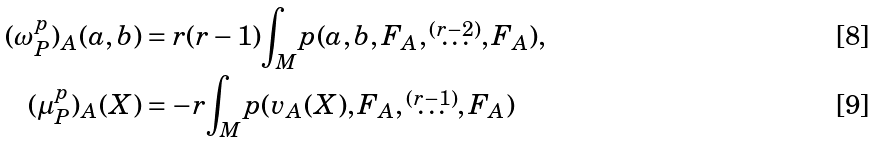<formula> <loc_0><loc_0><loc_500><loc_500>( \omega _ { P } ^ { p } ) _ { A } ( a , b ) & = r ( r - 1 ) { \int \nolimits _ { M } } p ( a , b , F _ { A } , \overset { ( r - 2 ) } { \dots } , F _ { A } ) , \\ ( \mu _ { P } ^ { p } ) _ { A } ( X ) & = - r { \int \nolimits _ { M } } p ( v _ { A } ( X ) , F _ { A } , \overset { ( r - 1 ) } { \dots } , F _ { A } )</formula> 